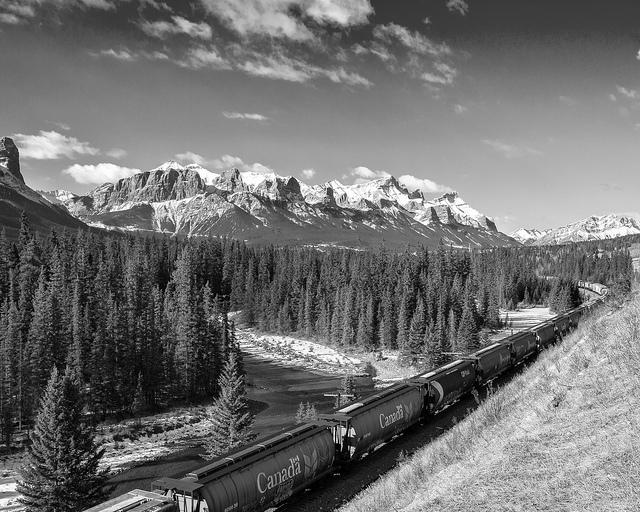Is the photo in color?
Keep it brief. No. What country's name can be seen on the train cars?
Write a very short answer. Canada. What landforms are in the back?
Concise answer only. Mountains. 